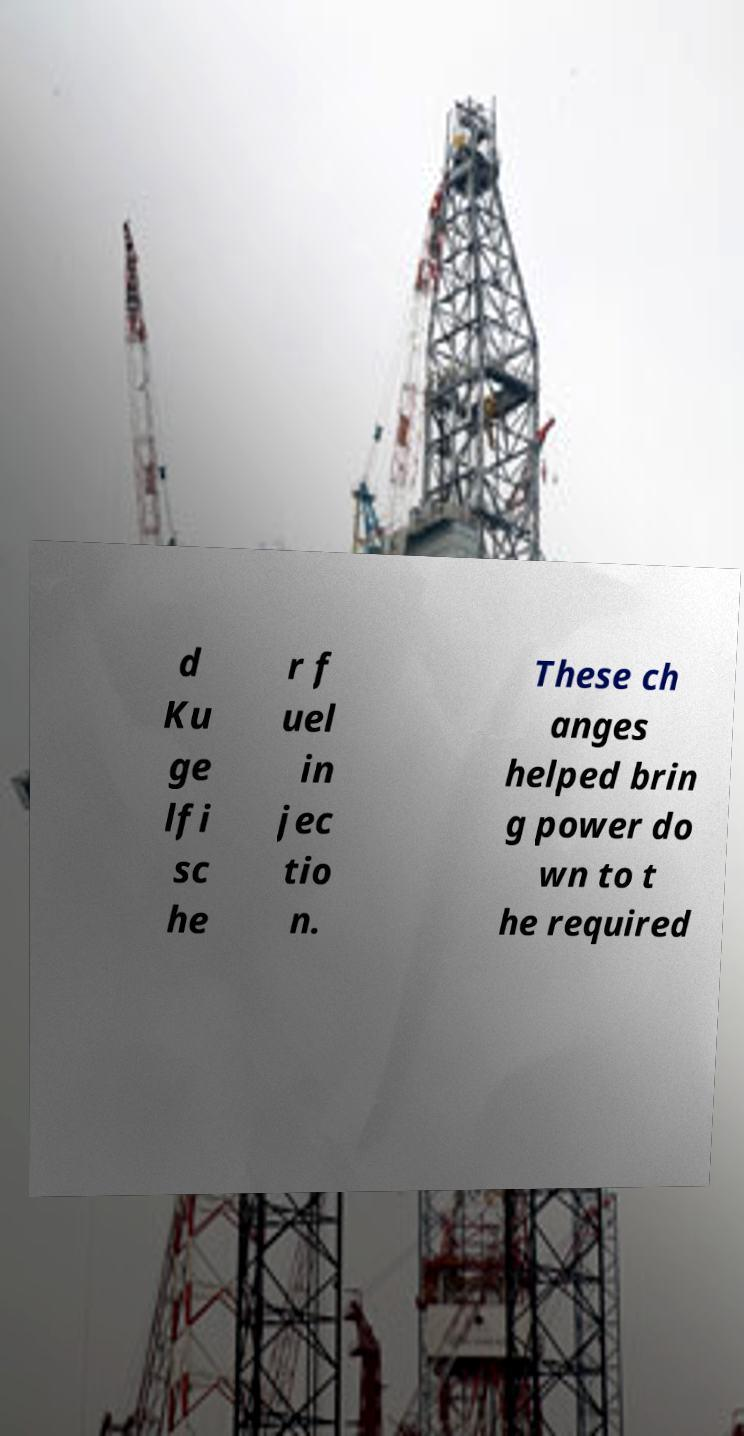Can you read and provide the text displayed in the image?This photo seems to have some interesting text. Can you extract and type it out for me? d Ku ge lfi sc he r f uel in jec tio n. These ch anges helped brin g power do wn to t he required 